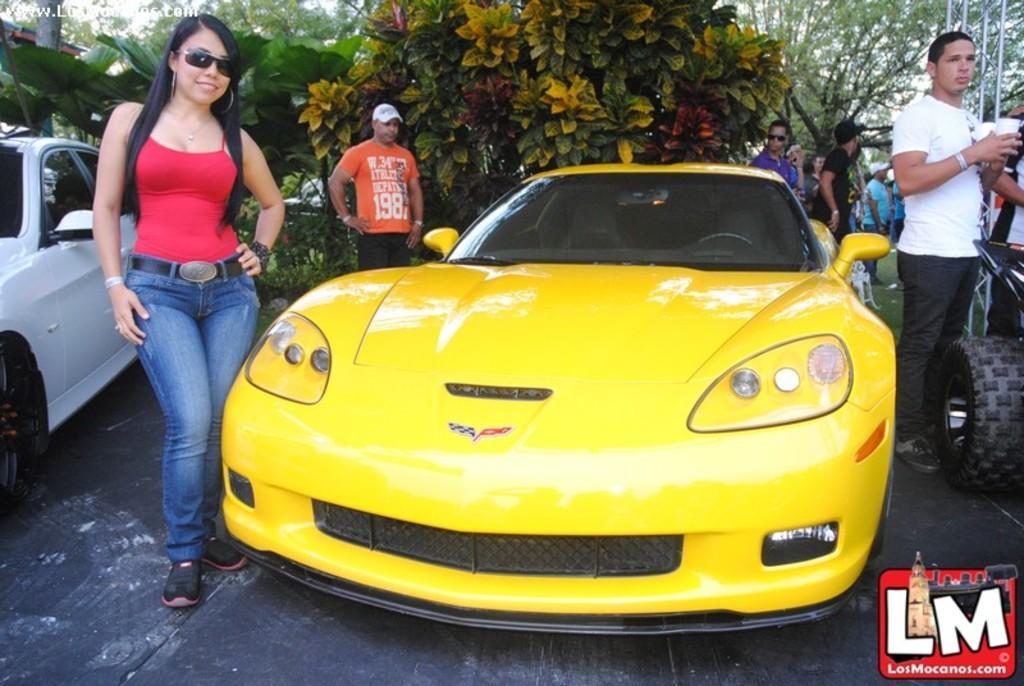Please provide a concise description of this image. In this image there is yellow color car, there are few persons , trees, plants visible in the middle , on the left side there is white color car and on the right side few persons, wheel ,stand visible. 